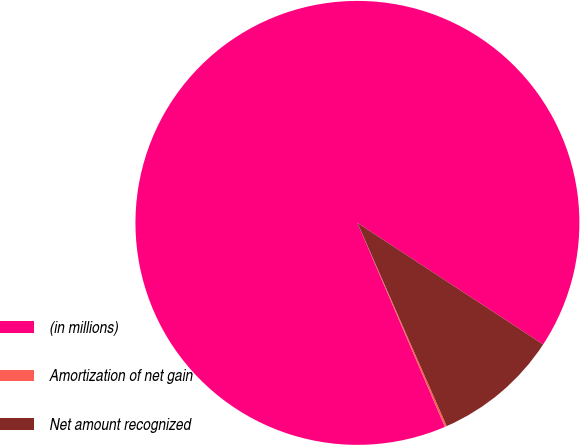Convert chart to OTSL. <chart><loc_0><loc_0><loc_500><loc_500><pie_chart><fcel>(in millions)<fcel>Amortization of net gain<fcel>Net amount recognized<nl><fcel>90.68%<fcel>0.14%<fcel>9.19%<nl></chart> 